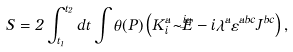<formula> <loc_0><loc_0><loc_500><loc_500>S = 2 \int _ { t _ { 1 } } ^ { t _ { 2 } } d t \int \theta ( P ) \left ( K _ { i } ^ { a } \dot { \tilde { E } ^ { i a } } - i \hat { \lambda } ^ { a } \varepsilon ^ { a b c } J ^ { b c } \right ) ,</formula> 